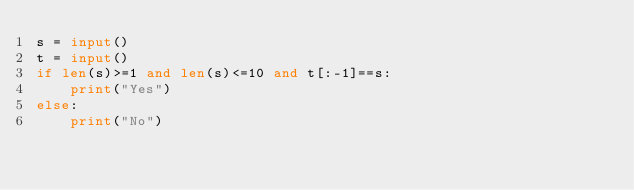<code> <loc_0><loc_0><loc_500><loc_500><_Python_>s = input()
t = input()
if len(s)>=1 and len(s)<=10 and t[:-1]==s:
    print("Yes")
else:
    print("No")</code> 